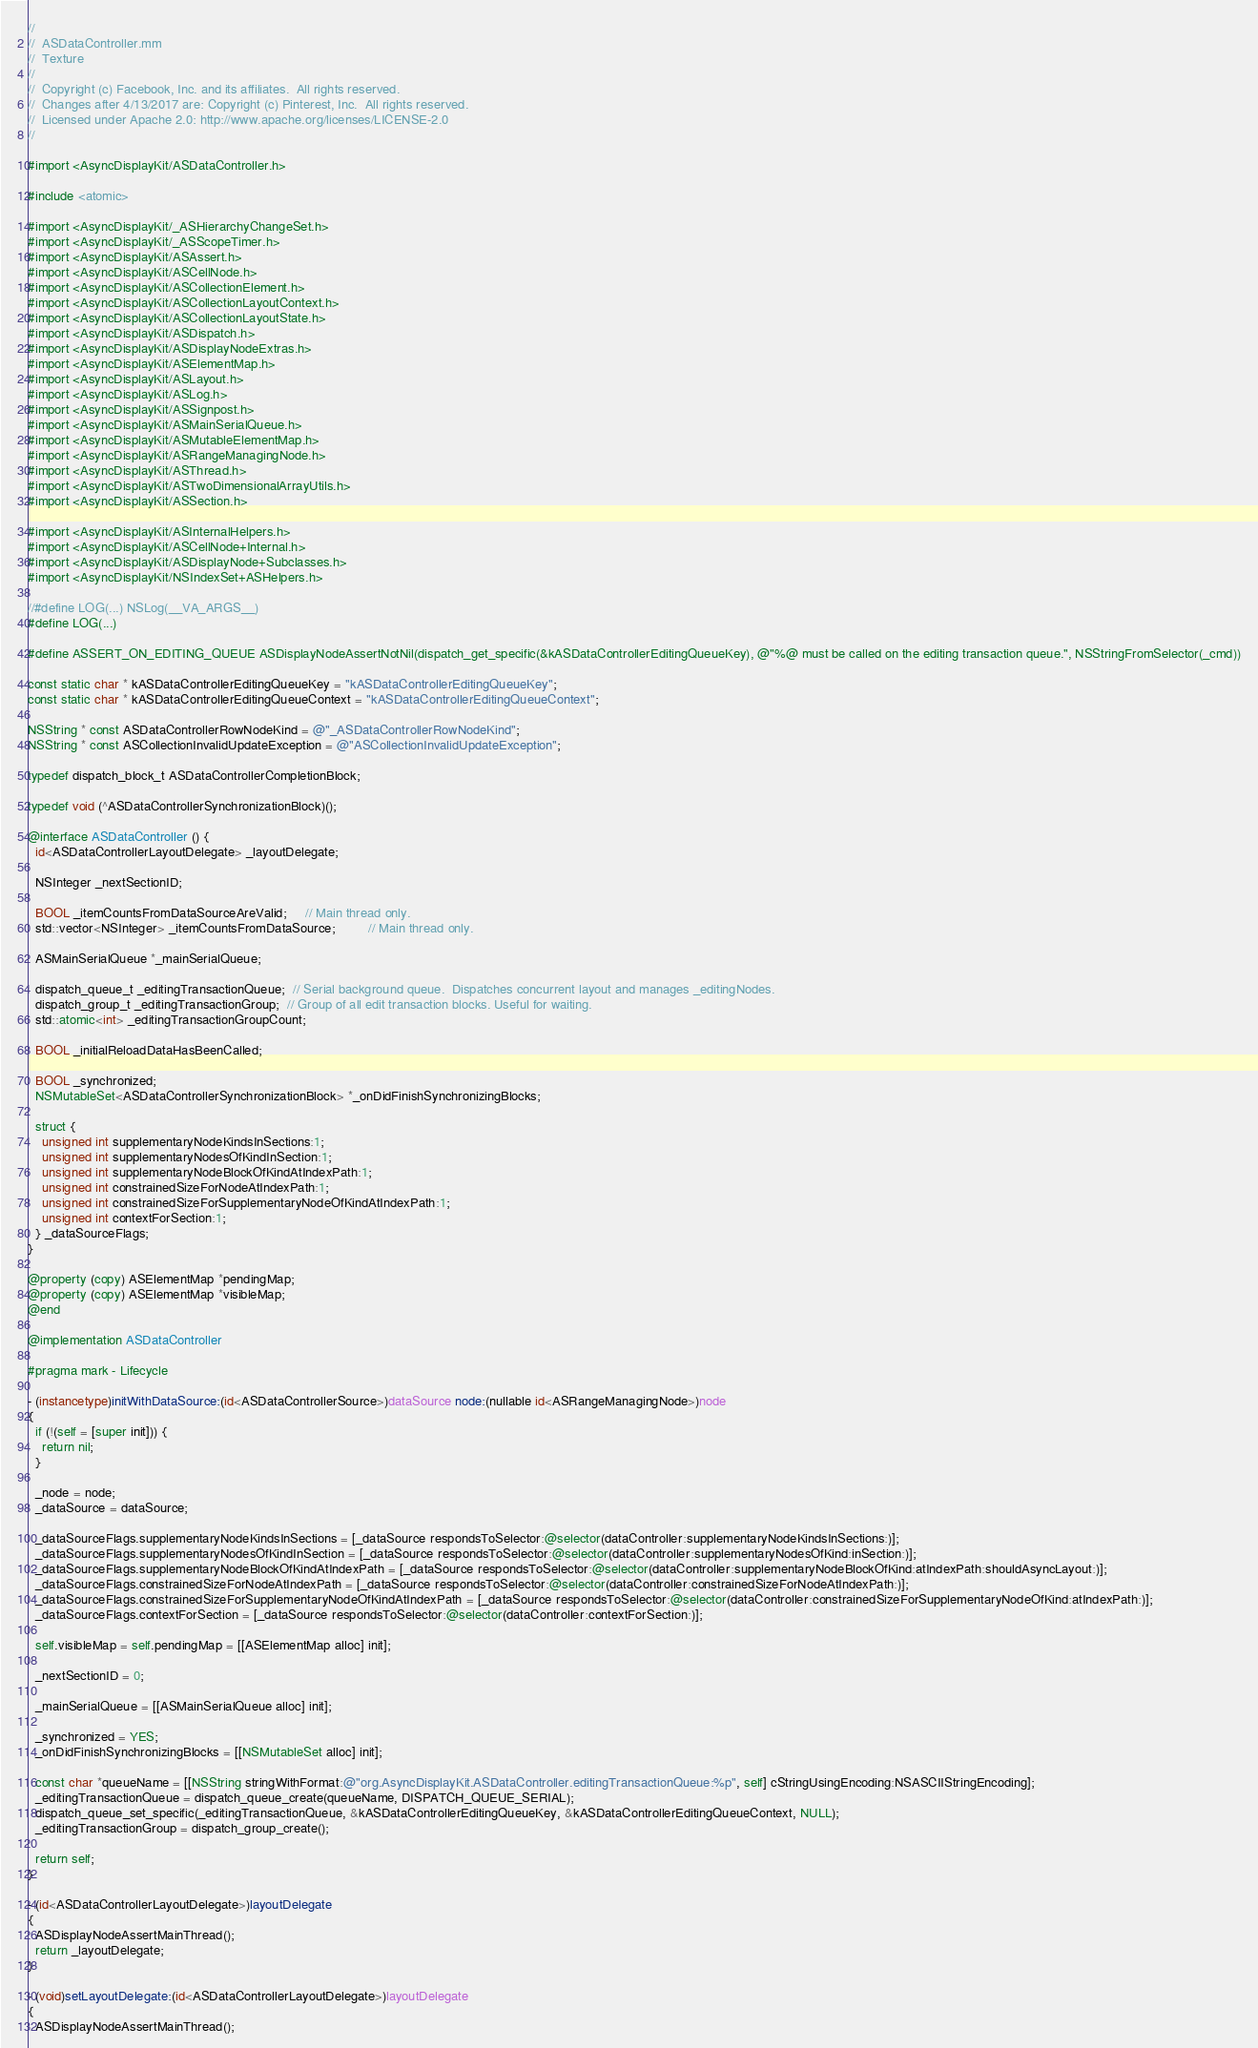<code> <loc_0><loc_0><loc_500><loc_500><_ObjectiveC_>//
//  ASDataController.mm
//  Texture
//
//  Copyright (c) Facebook, Inc. and its affiliates.  All rights reserved.
//  Changes after 4/13/2017 are: Copyright (c) Pinterest, Inc.  All rights reserved.
//  Licensed under Apache 2.0: http://www.apache.org/licenses/LICENSE-2.0
//

#import <AsyncDisplayKit/ASDataController.h>

#include <atomic>

#import <AsyncDisplayKit/_ASHierarchyChangeSet.h>
#import <AsyncDisplayKit/_ASScopeTimer.h>
#import <AsyncDisplayKit/ASAssert.h>
#import <AsyncDisplayKit/ASCellNode.h>
#import <AsyncDisplayKit/ASCollectionElement.h>
#import <AsyncDisplayKit/ASCollectionLayoutContext.h>
#import <AsyncDisplayKit/ASCollectionLayoutState.h>
#import <AsyncDisplayKit/ASDispatch.h>
#import <AsyncDisplayKit/ASDisplayNodeExtras.h>
#import <AsyncDisplayKit/ASElementMap.h>
#import <AsyncDisplayKit/ASLayout.h>
#import <AsyncDisplayKit/ASLog.h>
#import <AsyncDisplayKit/ASSignpost.h>
#import <AsyncDisplayKit/ASMainSerialQueue.h>
#import <AsyncDisplayKit/ASMutableElementMap.h>
#import <AsyncDisplayKit/ASRangeManagingNode.h>
#import <AsyncDisplayKit/ASThread.h>
#import <AsyncDisplayKit/ASTwoDimensionalArrayUtils.h>
#import <AsyncDisplayKit/ASSection.h>

#import <AsyncDisplayKit/ASInternalHelpers.h>
#import <AsyncDisplayKit/ASCellNode+Internal.h>
#import <AsyncDisplayKit/ASDisplayNode+Subclasses.h>
#import <AsyncDisplayKit/NSIndexSet+ASHelpers.h>

//#define LOG(...) NSLog(__VA_ARGS__)
#define LOG(...)

#define ASSERT_ON_EDITING_QUEUE ASDisplayNodeAssertNotNil(dispatch_get_specific(&kASDataControllerEditingQueueKey), @"%@ must be called on the editing transaction queue.", NSStringFromSelector(_cmd))

const static char * kASDataControllerEditingQueueKey = "kASDataControllerEditingQueueKey";
const static char * kASDataControllerEditingQueueContext = "kASDataControllerEditingQueueContext";

NSString * const ASDataControllerRowNodeKind = @"_ASDataControllerRowNodeKind";
NSString * const ASCollectionInvalidUpdateException = @"ASCollectionInvalidUpdateException";

typedef dispatch_block_t ASDataControllerCompletionBlock;

typedef void (^ASDataControllerSynchronizationBlock)();

@interface ASDataController () {
  id<ASDataControllerLayoutDelegate> _layoutDelegate;

  NSInteger _nextSectionID;
  
  BOOL _itemCountsFromDataSourceAreValid;     // Main thread only.
  std::vector<NSInteger> _itemCountsFromDataSource;         // Main thread only.
  
  ASMainSerialQueue *_mainSerialQueue;

  dispatch_queue_t _editingTransactionQueue;  // Serial background queue.  Dispatches concurrent layout and manages _editingNodes.
  dispatch_group_t _editingTransactionGroup;  // Group of all edit transaction blocks. Useful for waiting.
  std::atomic<int> _editingTransactionGroupCount;
  
  BOOL _initialReloadDataHasBeenCalled;

  BOOL _synchronized;
  NSMutableSet<ASDataControllerSynchronizationBlock> *_onDidFinishSynchronizingBlocks;

  struct {
    unsigned int supplementaryNodeKindsInSections:1;
    unsigned int supplementaryNodesOfKindInSection:1;
    unsigned int supplementaryNodeBlockOfKindAtIndexPath:1;
    unsigned int constrainedSizeForNodeAtIndexPath:1;
    unsigned int constrainedSizeForSupplementaryNodeOfKindAtIndexPath:1;
    unsigned int contextForSection:1;
  } _dataSourceFlags;
}

@property (copy) ASElementMap *pendingMap;
@property (copy) ASElementMap *visibleMap;
@end

@implementation ASDataController

#pragma mark - Lifecycle

- (instancetype)initWithDataSource:(id<ASDataControllerSource>)dataSource node:(nullable id<ASRangeManagingNode>)node
{
  if (!(self = [super init])) {
    return nil;
  }
  
  _node = node;
  _dataSource = dataSource;
  
  _dataSourceFlags.supplementaryNodeKindsInSections = [_dataSource respondsToSelector:@selector(dataController:supplementaryNodeKindsInSections:)];
  _dataSourceFlags.supplementaryNodesOfKindInSection = [_dataSource respondsToSelector:@selector(dataController:supplementaryNodesOfKind:inSection:)];
  _dataSourceFlags.supplementaryNodeBlockOfKindAtIndexPath = [_dataSource respondsToSelector:@selector(dataController:supplementaryNodeBlockOfKind:atIndexPath:shouldAsyncLayout:)];
  _dataSourceFlags.constrainedSizeForNodeAtIndexPath = [_dataSource respondsToSelector:@selector(dataController:constrainedSizeForNodeAtIndexPath:)];
  _dataSourceFlags.constrainedSizeForSupplementaryNodeOfKindAtIndexPath = [_dataSource respondsToSelector:@selector(dataController:constrainedSizeForSupplementaryNodeOfKind:atIndexPath:)];
  _dataSourceFlags.contextForSection = [_dataSource respondsToSelector:@selector(dataController:contextForSection:)];

  self.visibleMap = self.pendingMap = [[ASElementMap alloc] init];
  
  _nextSectionID = 0;
  
  _mainSerialQueue = [[ASMainSerialQueue alloc] init];

  _synchronized = YES;
  _onDidFinishSynchronizingBlocks = [[NSMutableSet alloc] init];
  
  const char *queueName = [[NSString stringWithFormat:@"org.AsyncDisplayKit.ASDataController.editingTransactionQueue:%p", self] cStringUsingEncoding:NSASCIIStringEncoding];
  _editingTransactionQueue = dispatch_queue_create(queueName, DISPATCH_QUEUE_SERIAL);
  dispatch_queue_set_specific(_editingTransactionQueue, &kASDataControllerEditingQueueKey, &kASDataControllerEditingQueueContext, NULL);
  _editingTransactionGroup = dispatch_group_create();
  
  return self;
}

- (id<ASDataControllerLayoutDelegate>)layoutDelegate
{
  ASDisplayNodeAssertMainThread();
  return _layoutDelegate;
}

- (void)setLayoutDelegate:(id<ASDataControllerLayoutDelegate>)layoutDelegate
{
  ASDisplayNodeAssertMainThread();</code> 